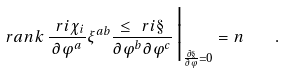<formula> <loc_0><loc_0><loc_500><loc_500>r a n k \, \frac { \ r i \chi _ { i } } { \partial \varphi ^ { a } } \xi ^ { a b } \frac { \leq \ r i \S } { \partial \varphi ^ { b } \partial \varphi ^ { c } } \, \Big | _ { \frac { \partial \S } { \partial \varphi } = 0 } = n \quad .</formula> 